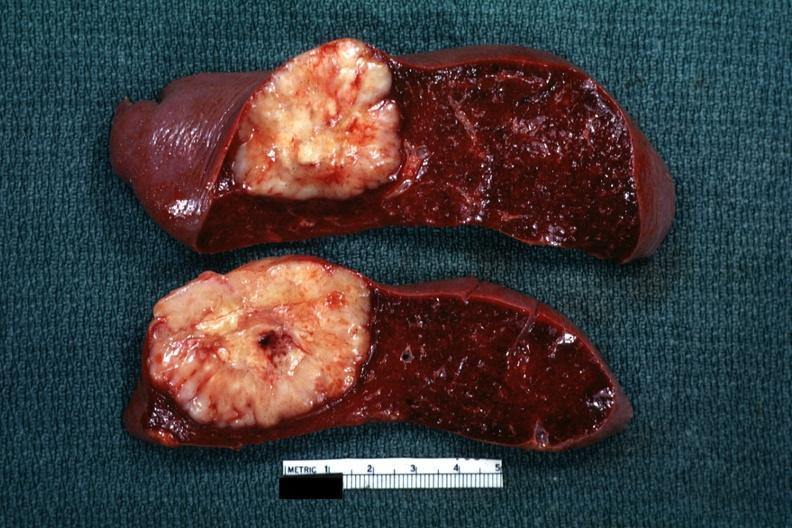s large cell lymphoma present?
Answer the question using a single word or phrase. Yes 